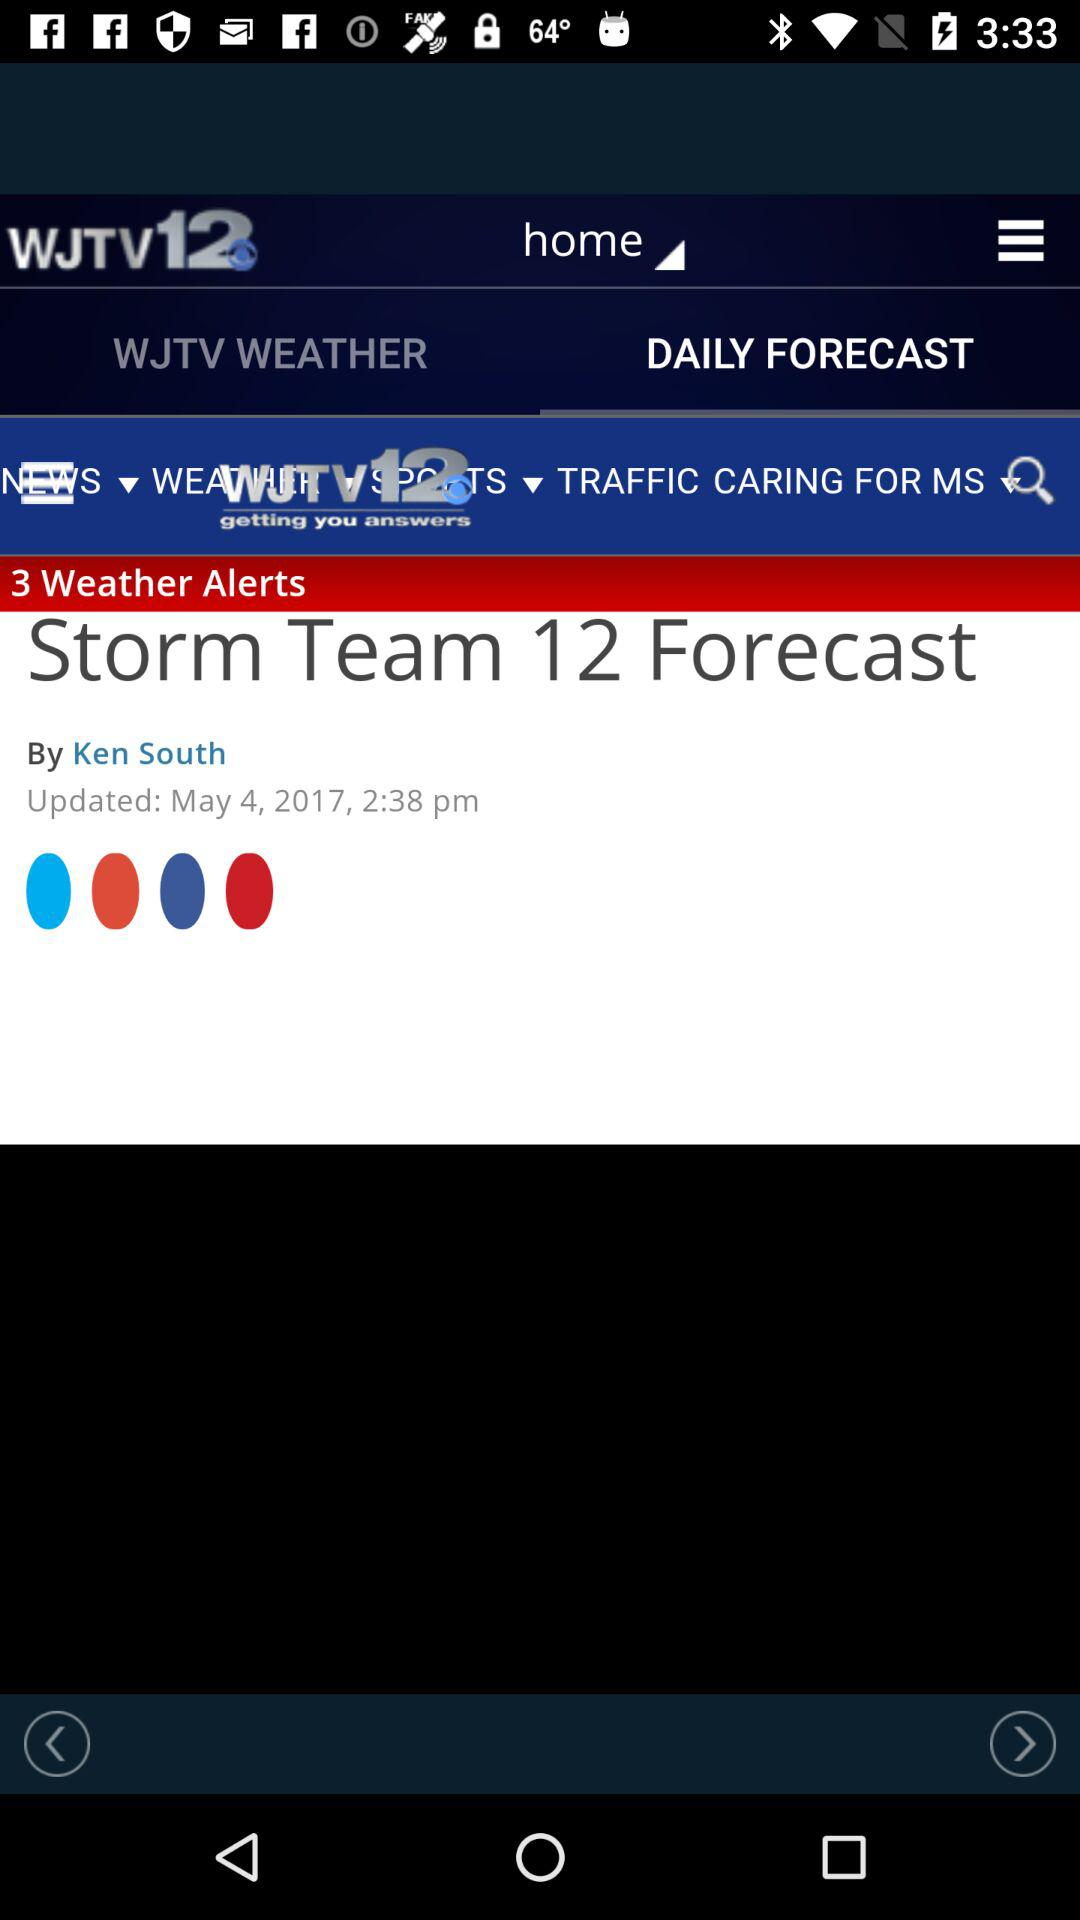At what time was the post updated? The post was updated at 2:38 p.m. 